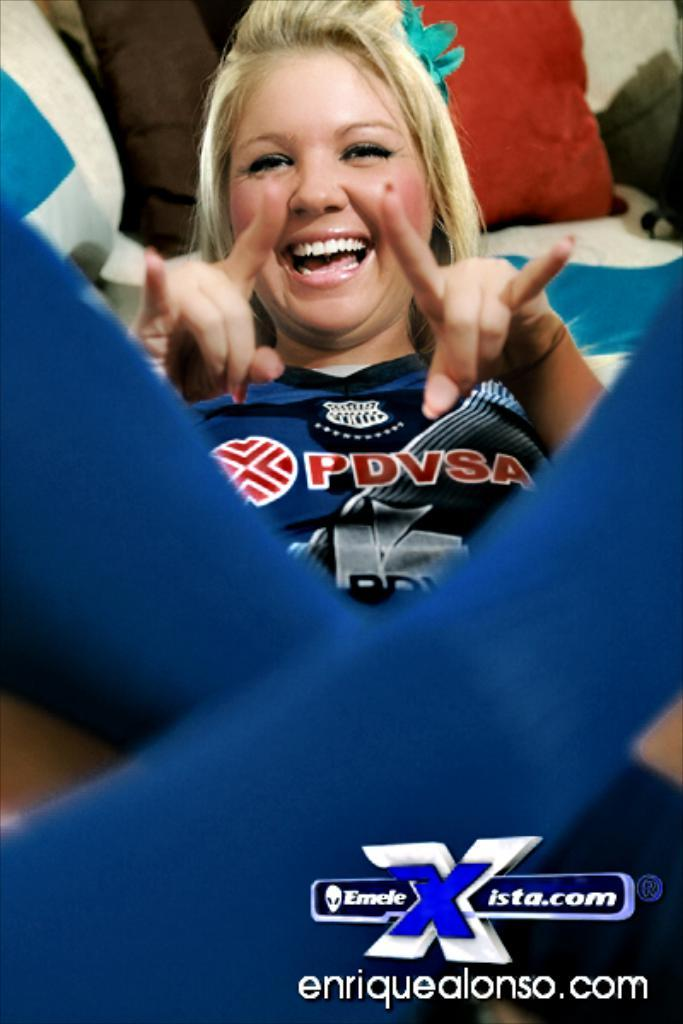<image>
Summarize the visual content of the image. the photo of the lady wearing PDVSA shirt is by enriquealonso.com 